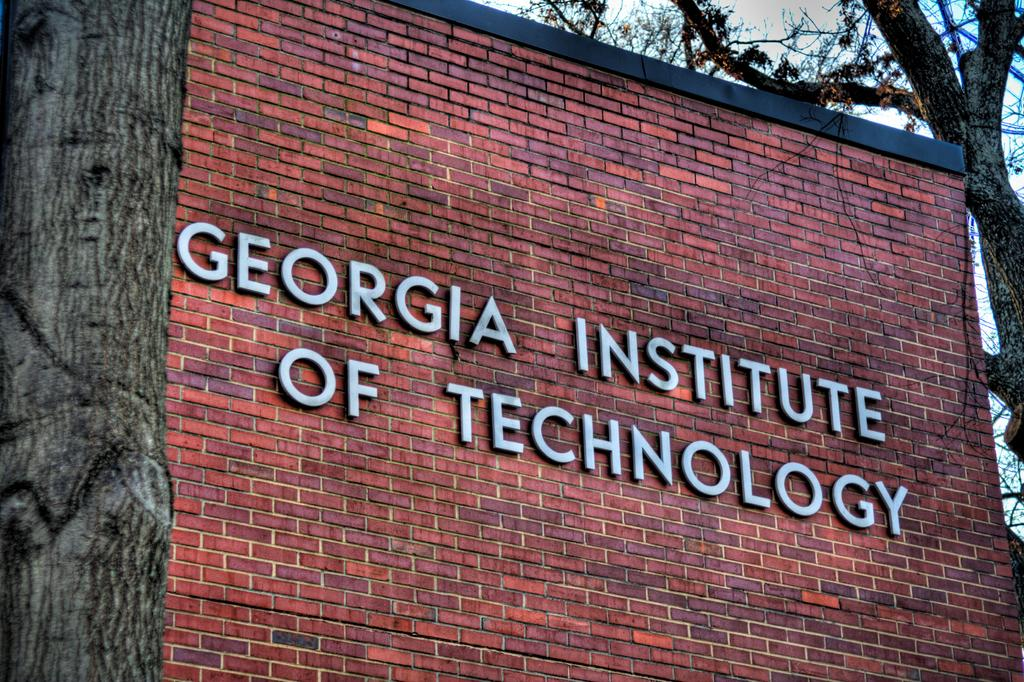What object is located on the left side of the image? There is a trunk on the left side of the image. What can be seen in the center of the image? There is text on a wall in the center of the image. What type of vegetation is in the background of the image? There is a tree in the background of the image. What is visible in the background of the image besides the tree? The sky is visible in the background of the image. How many pizzas are being served on the receipt in the image? There is no pizza or receipt present in the image. What type of beef is mentioned in the text on the wall in the image? There is no beef mentioned in the text on the wall in the image. 